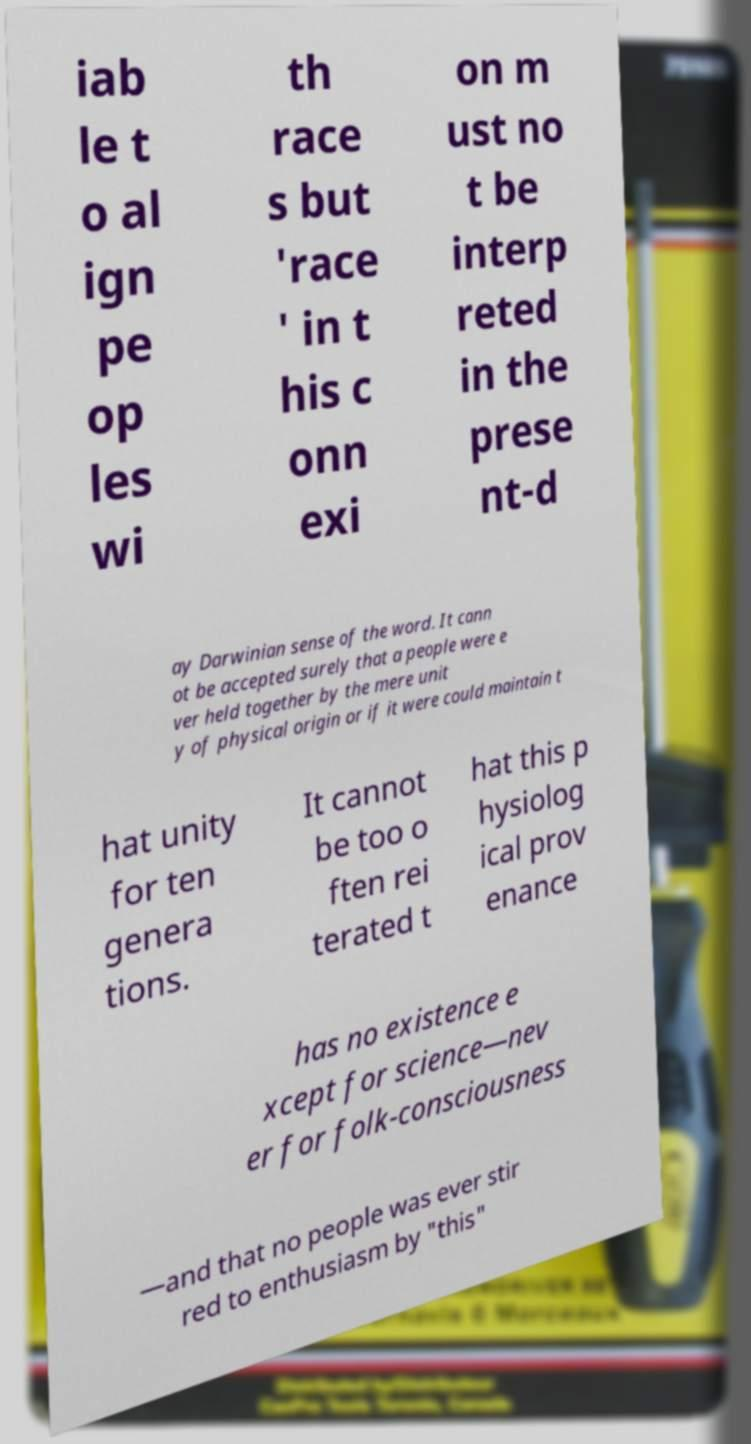For documentation purposes, I need the text within this image transcribed. Could you provide that? iab le t o al ign pe op les wi th race s but 'race ' in t his c onn exi on m ust no t be interp reted in the prese nt-d ay Darwinian sense of the word. It cann ot be accepted surely that a people were e ver held together by the mere unit y of physical origin or if it were could maintain t hat unity for ten genera tions. It cannot be too o ften rei terated t hat this p hysiolog ical prov enance has no existence e xcept for science—nev er for folk-consciousness —and that no people was ever stir red to enthusiasm by "this" 